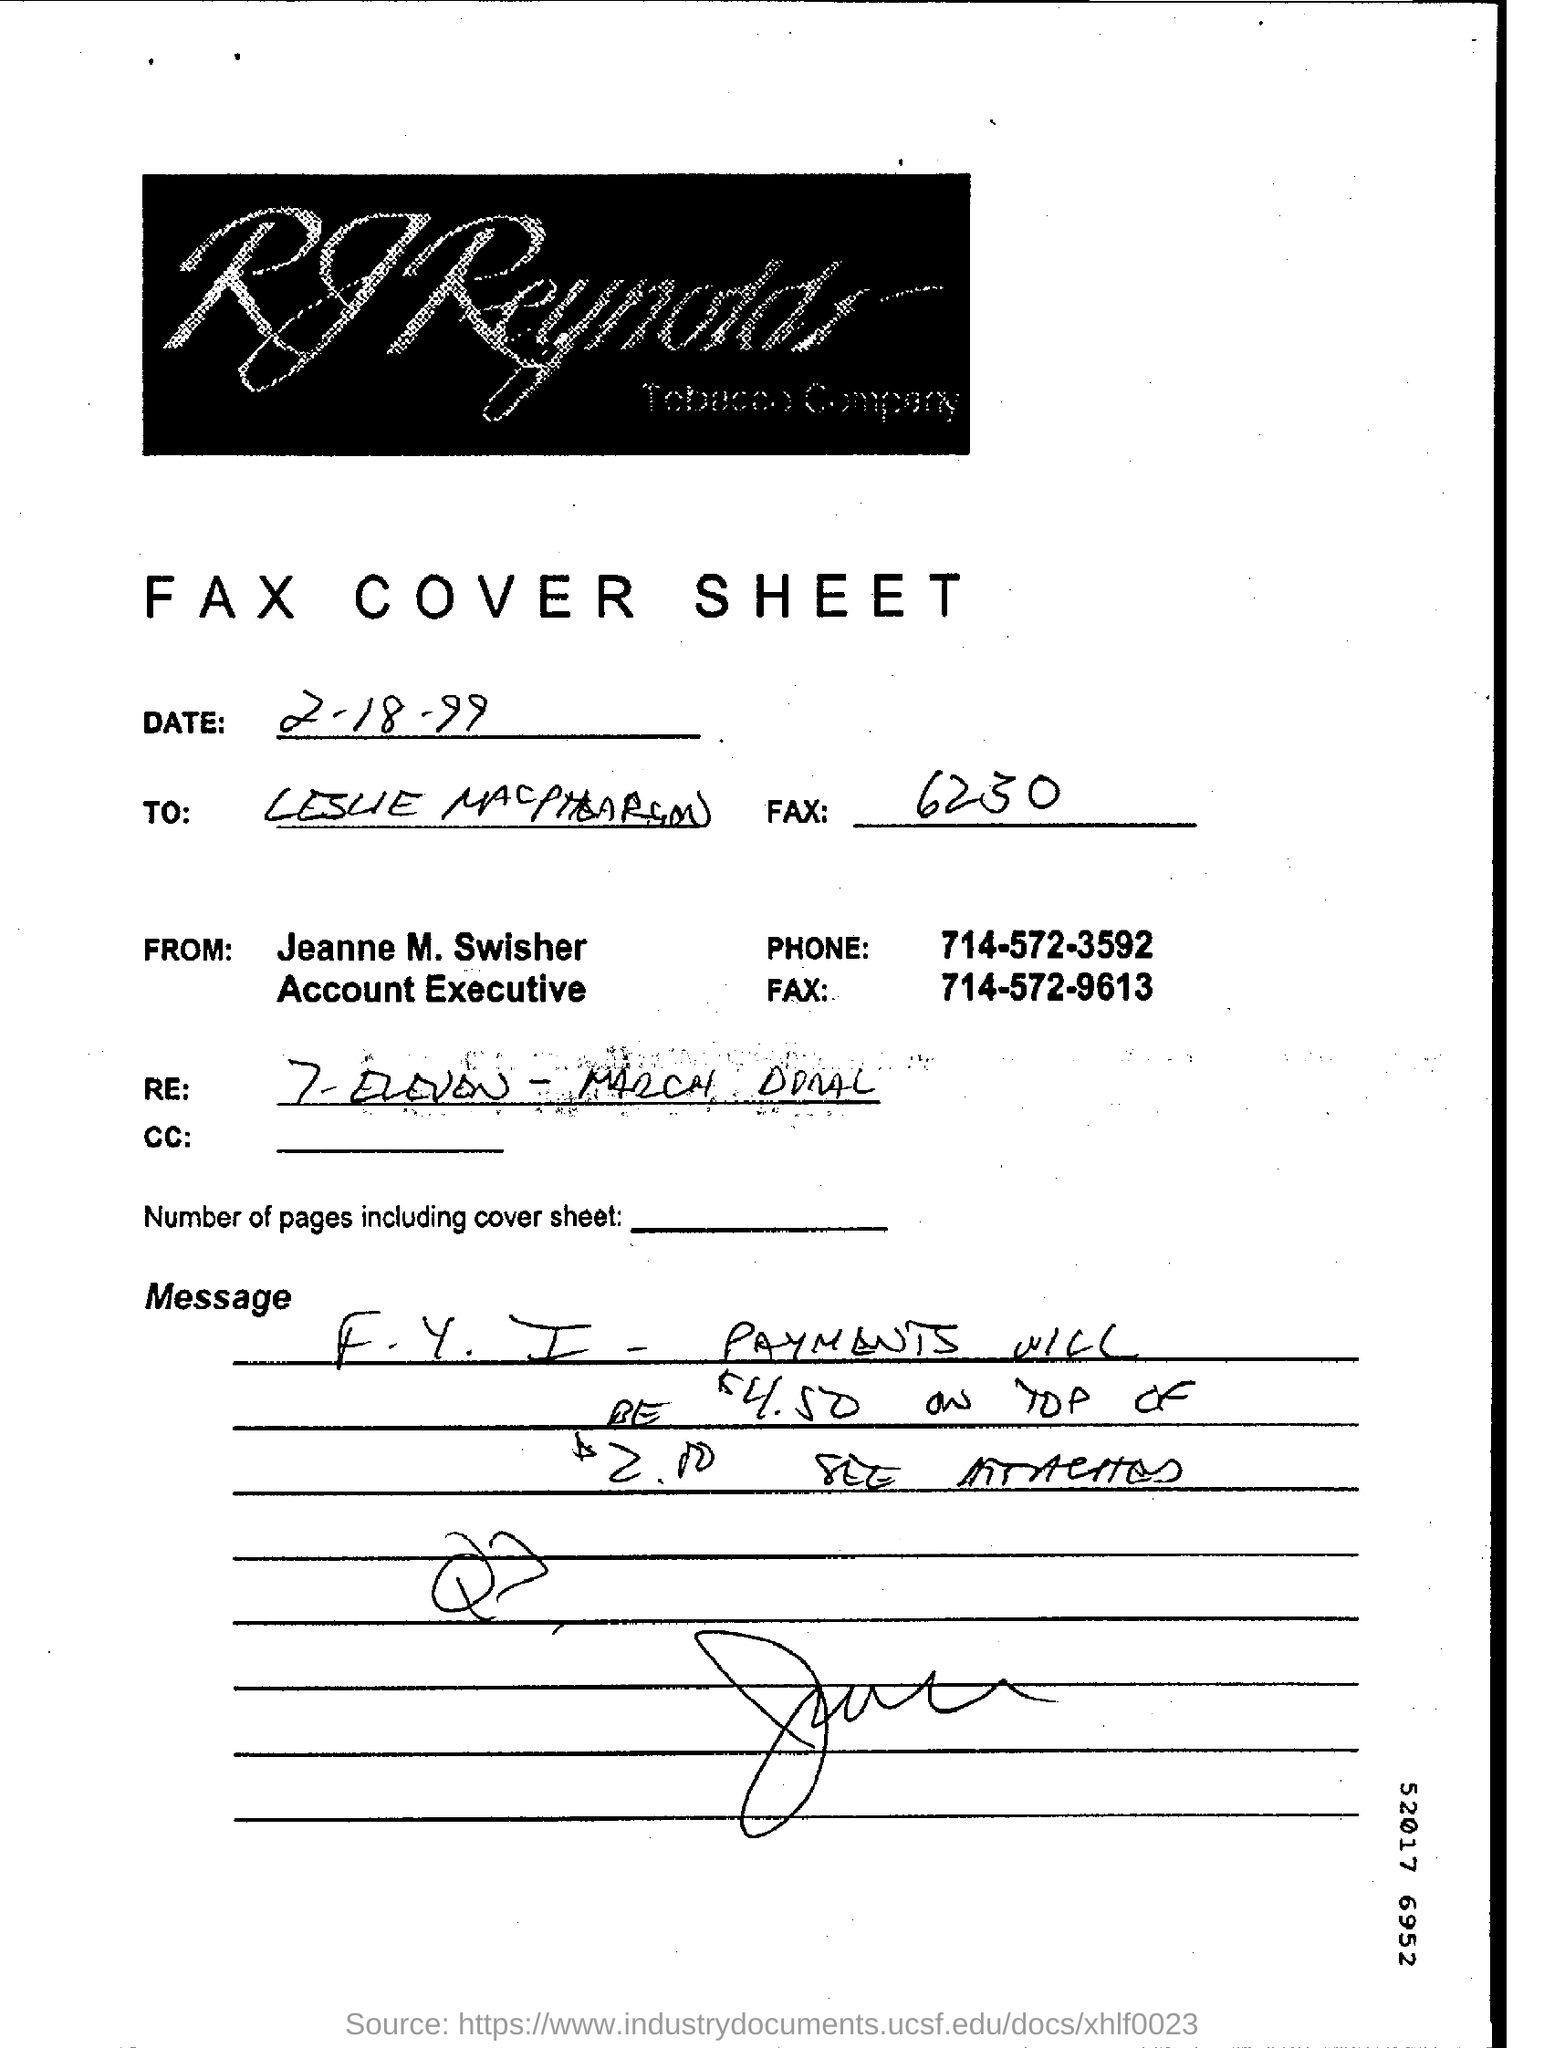Give some essential details in this illustration. Fax cover sheet is a type of document. Jeanne M. Swisher is the account executive. The fax cover sheet was dated February 18, 1999. 